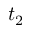<formula> <loc_0><loc_0><loc_500><loc_500>t _ { 2 }</formula> 